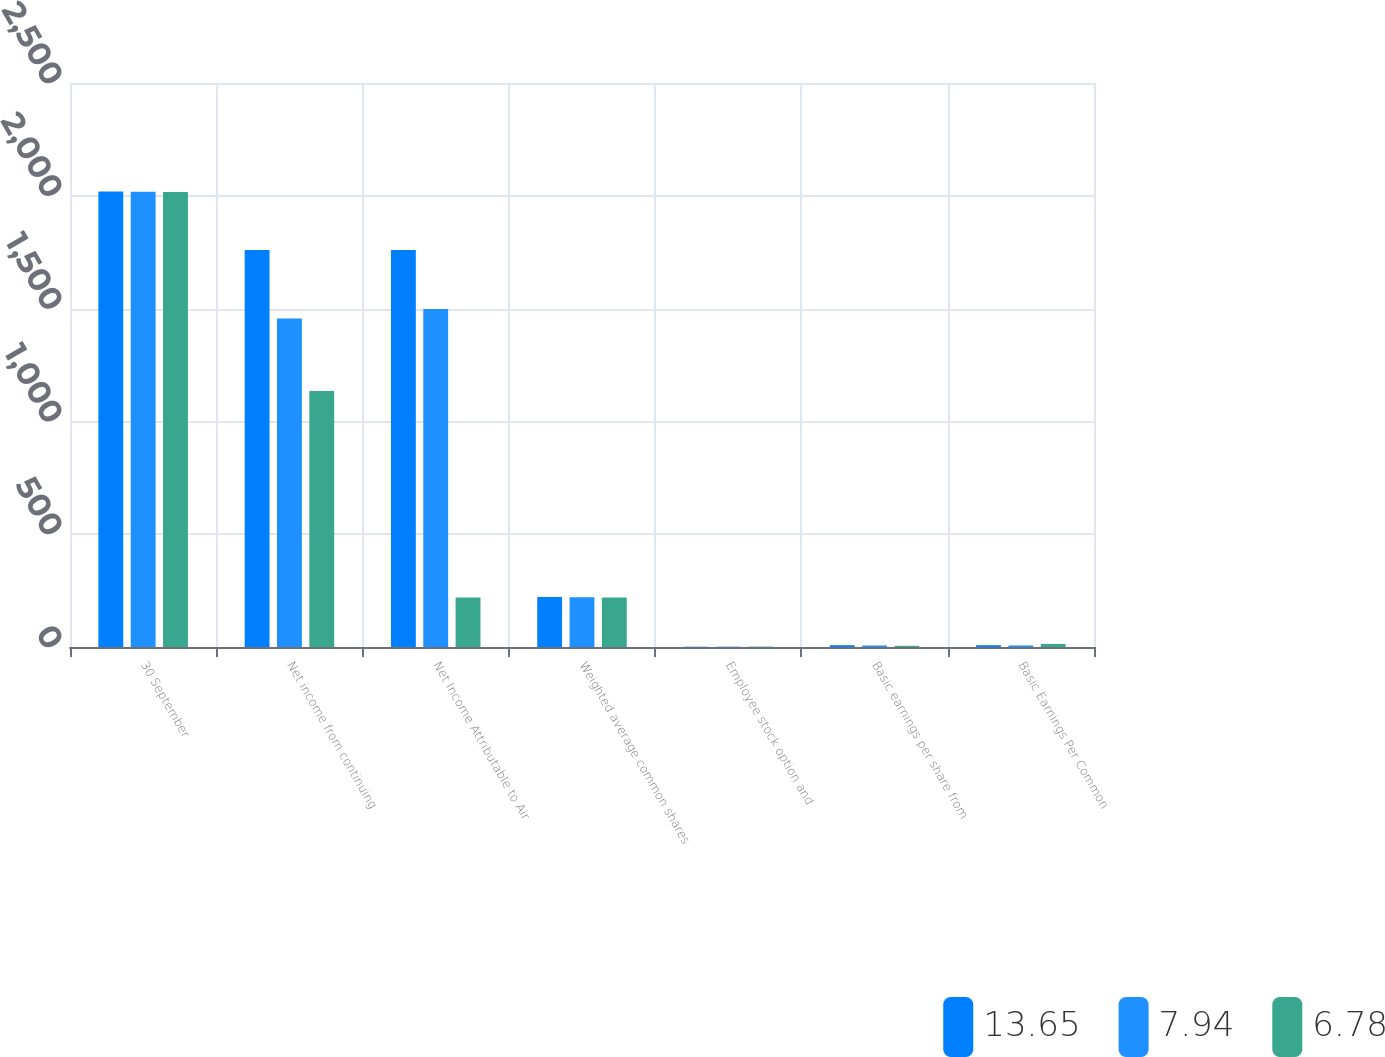Convert chart to OTSL. <chart><loc_0><loc_0><loc_500><loc_500><stacked_bar_chart><ecel><fcel>30 September<fcel>Net income from continuing<fcel>Net Income Attributable to Air<fcel>Weighted average common shares<fcel>Employee stock option and<fcel>Basic earnings per share from<fcel>Basic Earnings Per Common<nl><fcel>13.65<fcel>2019<fcel>1760<fcel>1760<fcel>221.6<fcel>1.3<fcel>7.99<fcel>7.99<nl><fcel>7.94<fcel>2018<fcel>1455.6<fcel>1497.8<fcel>220.8<fcel>1.5<fcel>6.64<fcel>6.83<nl><fcel>6.78<fcel>2017<fcel>1134.4<fcel>219.8<fcel>219.8<fcel>1.8<fcel>5.2<fcel>13.76<nl></chart> 